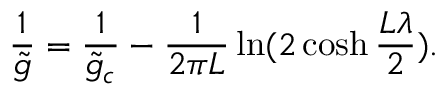<formula> <loc_0><loc_0><loc_500><loc_500>{ \frac { 1 } { \tilde { g } } } = { \frac { 1 } { \tilde { g } _ { c } } } - { \frac { 1 } { 2 \pi L } } \ln ( 2 \cosh { \frac { L \lambda } { 2 } } ) .</formula> 